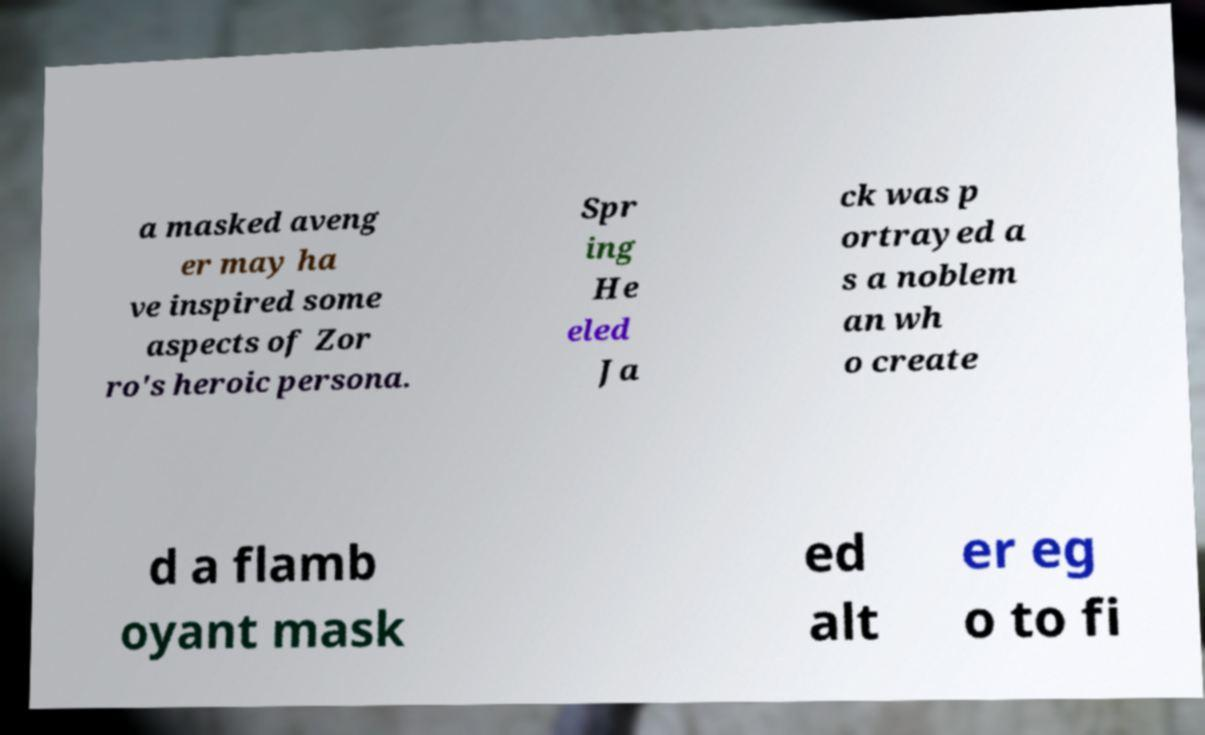I need the written content from this picture converted into text. Can you do that? a masked aveng er may ha ve inspired some aspects of Zor ro's heroic persona. Spr ing He eled Ja ck was p ortrayed a s a noblem an wh o create d a flamb oyant mask ed alt er eg o to fi 